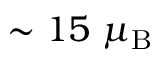<formula> <loc_0><loc_0><loc_500><loc_500>\sim 1 5 \mu _ { B }</formula> 